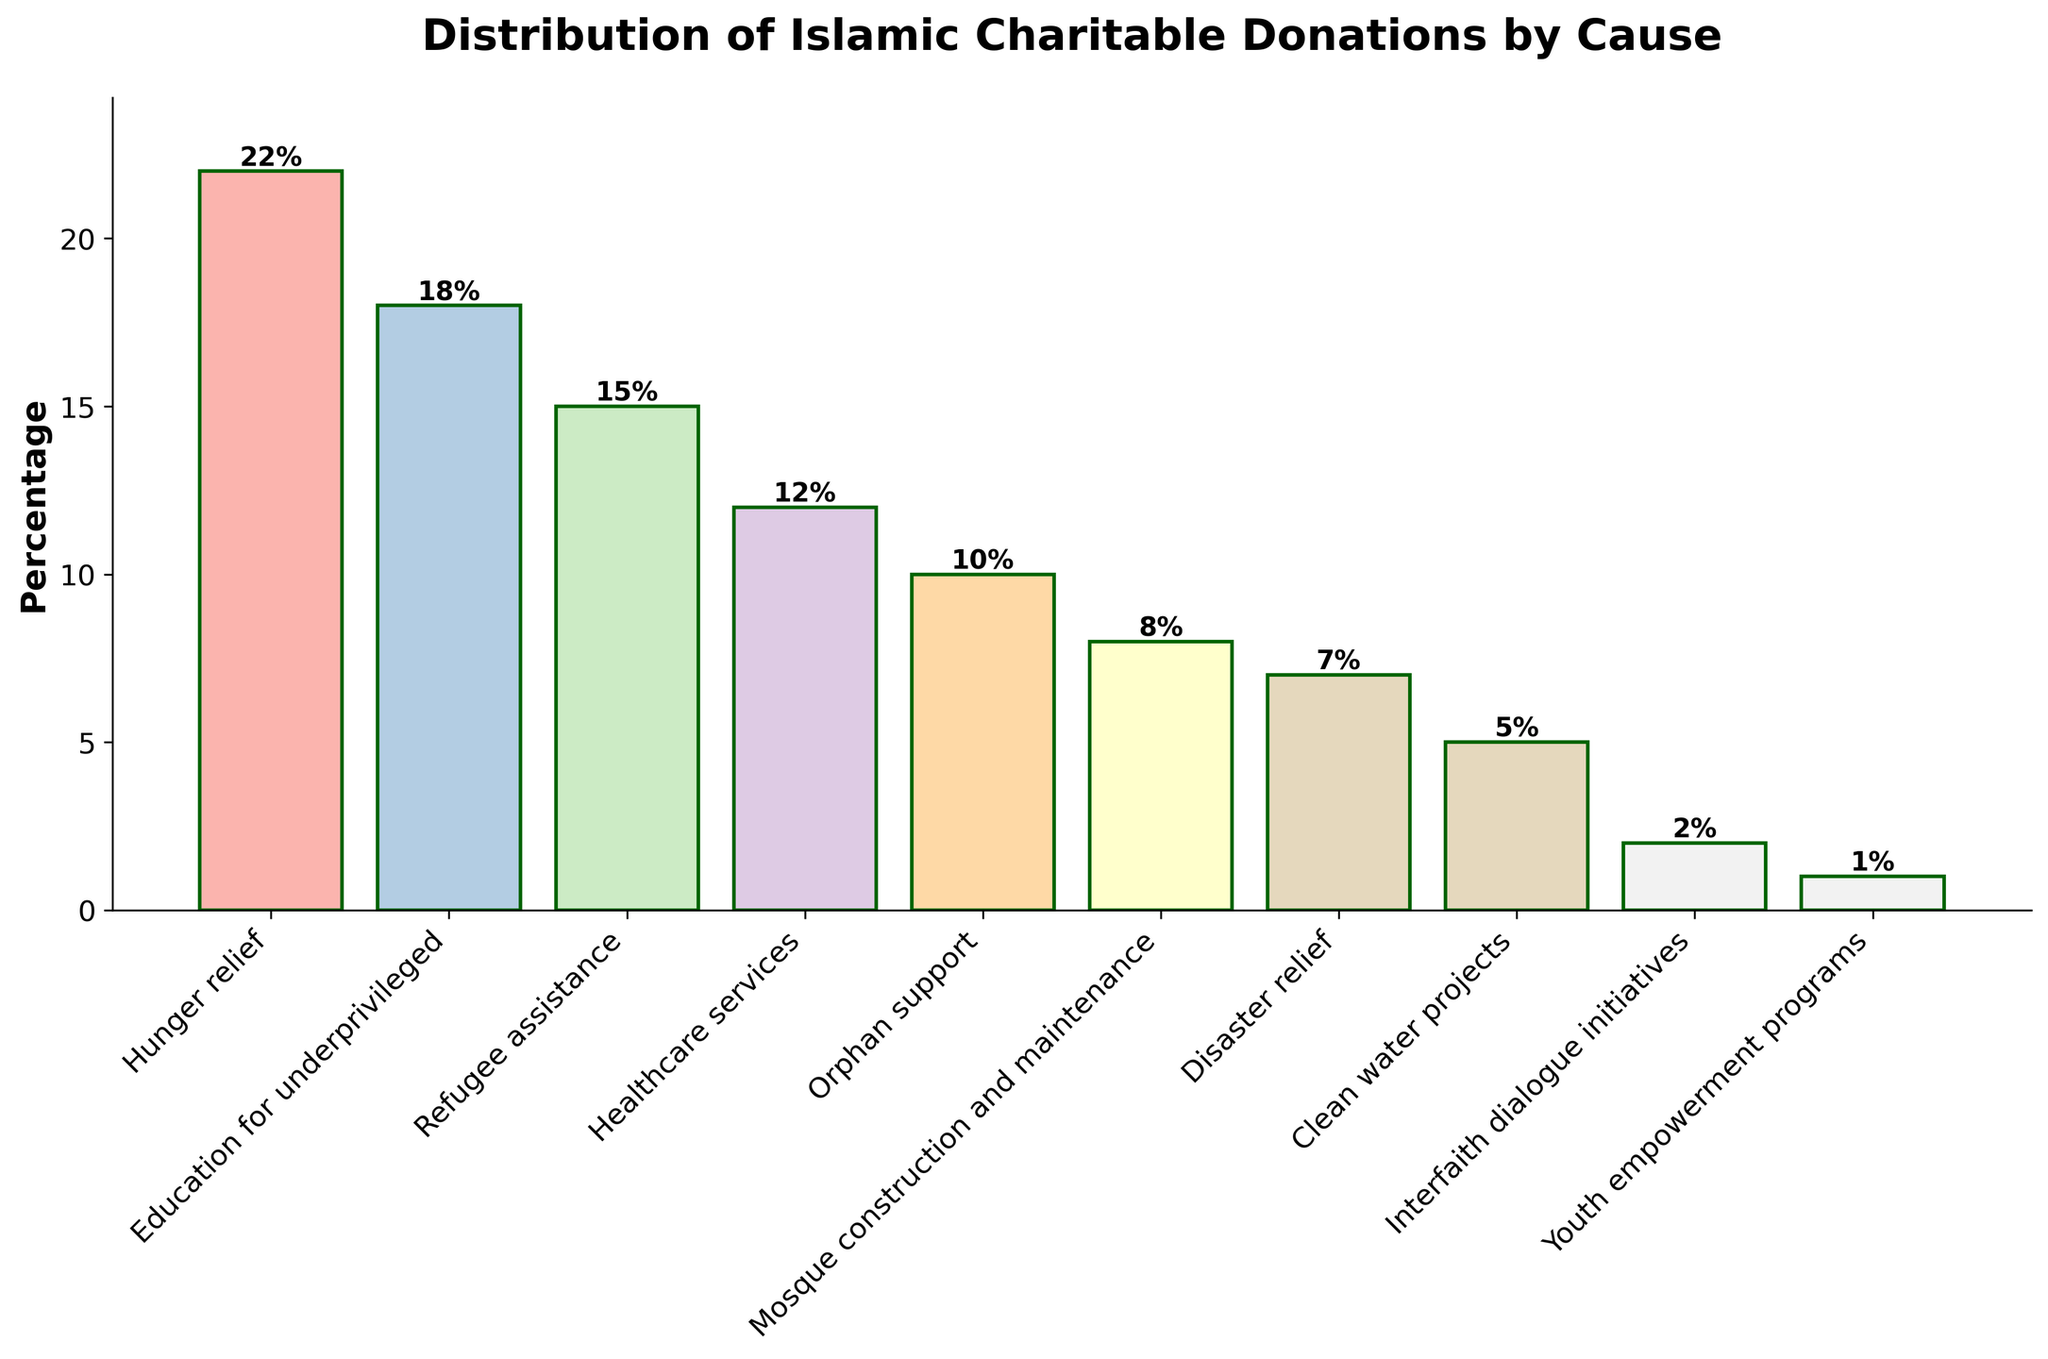Which cause received the highest percentage of donations? The tallest bar represents the cause with the highest percentage of donations. The "Hunger relief" bar is the tallest.
Answer: Hunger relief What is the combined percentage of donations for healthcare services, orphan support, and mosque construction and maintenance? Look at the heights of the bars for healthcare services (12%), orphan support (10%), and mosque construction and maintenance (8%). Sum these percentages: 12% + 10% + 8% = 30%.
Answer: 30% Which cause received fewer donations: disaster relief or clean water projects? Compare the heights of the bars for disaster relief (7%) and clean water projects (5%). 5% (clean water projects) is less than 7% (disaster relief).
Answer: Clean water projects How much more percentage of donations was directed towards hunger relief compared to youth empowerment programs? Subtract the percentage of donations for youth empowerment programs (1%) from that for hunger relief (22%): 22% - 1% = 21%.
Answer: 21% What is the difference in the percentages of donations for interfaith dialogue initiatives and refugee assistance? Subtract the percentage of donations for interfaith dialogue initiatives (2%) from that for refugee assistance (15%): 15% - 2% = 13%.
Answer: 13% Which causes account for more than 15% of the donations? Identify the bars with heights greater than 15%. Hunger relief (22%) and education for underprivileged (18%) are the two causes exceeding 15%.
Answer: Hunger relief, Education for underprivileged What is the percentage difference between the largest and smallest causes by donation? Identify the largest (Hunger relief, 22%) and the smallest (Youth empowerment programs, 1%). Subtract the smallest from the largest: 22% - 1% = 21%.
Answer: 21% Are there more donations directed towards education for the underprivileged or orphan support? Compare the heights of the bars for education for the underprivileged (18%) and orphan support (10%). 18% (education for the underprivileged) is greater.
Answer: Education for underprivileged 